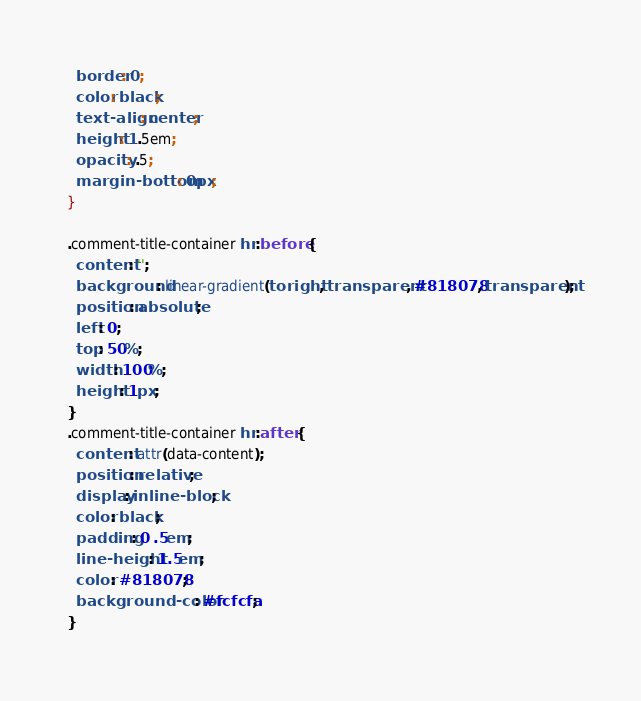<code> <loc_0><loc_0><loc_500><loc_500><_CSS_>  border: 0;
  color: black;
  text-align: center;
  height: 1.5em;
  opacity: .5;
  margin-bottom: 0px;
}

.comment-title-container hr:before {
  content: '';
  background: linear-gradient(to right, transparent, #818078, transparent);
  position: absolute;
  left: 0;
  top: 50%;
  width: 100%;
  height: 1px;
}
.comment-title-container hr:after {
  content: attr(data-content);
  position: relative;
  display: inline-block;
  color: black;
  padding: 0 .5em;
  line-height: 1.5em;
  color: #818078;
  background-color: #fcfcfa;
}</code> 